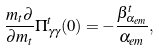<formula> <loc_0><loc_0><loc_500><loc_500>\frac { m _ { t } \partial } { \partial m _ { t } } \Pi _ { \gamma \gamma } ^ { t } ( 0 ) = - \frac { \beta _ { \alpha _ { e m } } ^ { t } } { \alpha _ { e m } } ,</formula> 